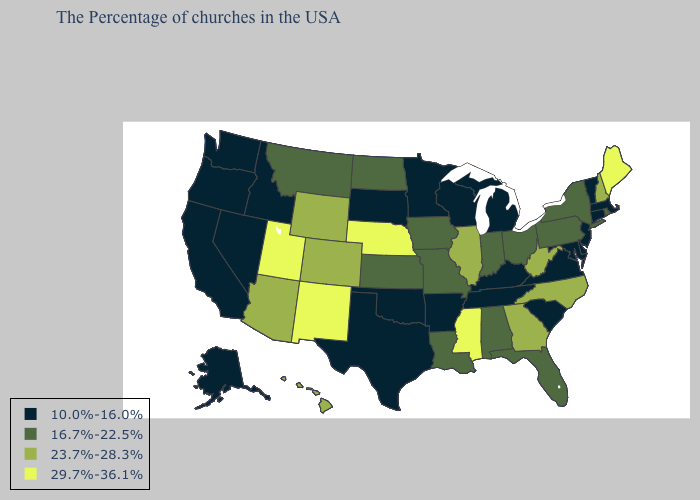What is the value of Georgia?
Answer briefly. 23.7%-28.3%. Name the states that have a value in the range 10.0%-16.0%?
Short answer required. Massachusetts, Vermont, Connecticut, New Jersey, Delaware, Maryland, Virginia, South Carolina, Michigan, Kentucky, Tennessee, Wisconsin, Arkansas, Minnesota, Oklahoma, Texas, South Dakota, Idaho, Nevada, California, Washington, Oregon, Alaska. Name the states that have a value in the range 10.0%-16.0%?
Quick response, please. Massachusetts, Vermont, Connecticut, New Jersey, Delaware, Maryland, Virginia, South Carolina, Michigan, Kentucky, Tennessee, Wisconsin, Arkansas, Minnesota, Oklahoma, Texas, South Dakota, Idaho, Nevada, California, Washington, Oregon, Alaska. What is the highest value in the Northeast ?
Concise answer only. 29.7%-36.1%. What is the value of Arkansas?
Write a very short answer. 10.0%-16.0%. Name the states that have a value in the range 23.7%-28.3%?
Short answer required. New Hampshire, North Carolina, West Virginia, Georgia, Illinois, Wyoming, Colorado, Arizona, Hawaii. Among the states that border Tennessee , does Kentucky have the highest value?
Give a very brief answer. No. Does California have the same value as Nebraska?
Give a very brief answer. No. Which states have the lowest value in the West?
Be succinct. Idaho, Nevada, California, Washington, Oregon, Alaska. Name the states that have a value in the range 23.7%-28.3%?
Write a very short answer. New Hampshire, North Carolina, West Virginia, Georgia, Illinois, Wyoming, Colorado, Arizona, Hawaii. Does the first symbol in the legend represent the smallest category?
Write a very short answer. Yes. How many symbols are there in the legend?
Be succinct. 4. Among the states that border Illinois , does Wisconsin have the lowest value?
Quick response, please. Yes. Among the states that border Delaware , which have the lowest value?
Write a very short answer. New Jersey, Maryland. What is the value of Nevada?
Short answer required. 10.0%-16.0%. 